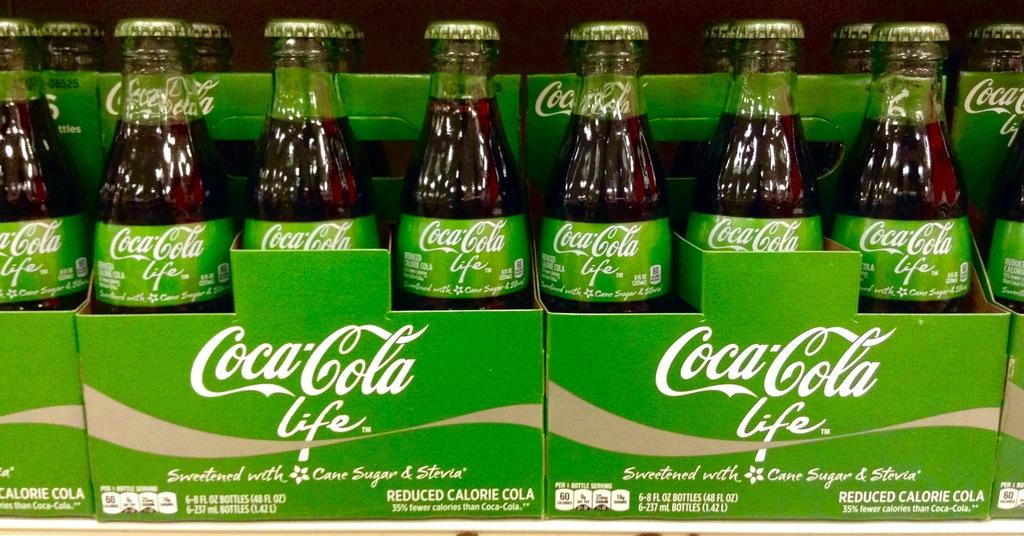What type of coke is this?
Keep it short and to the point. Life. What color label does this brand use?
Ensure brevity in your answer.  Green. 